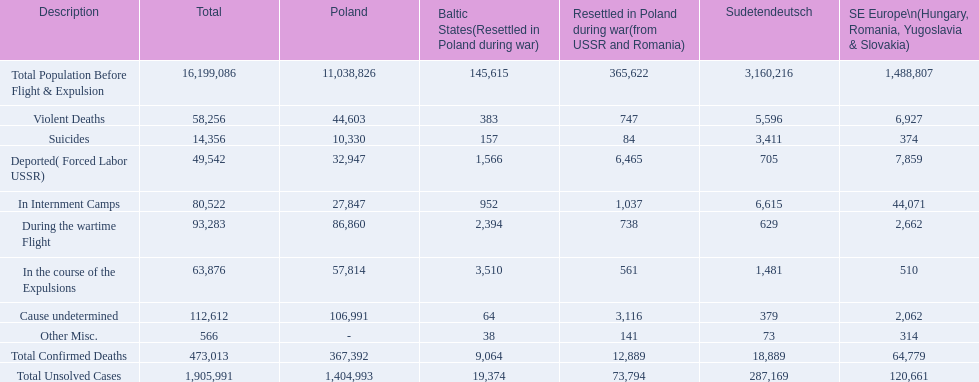What are the different descriptions? Total Population Before Flight & Expulsion, Violent Deaths, Suicides, Deported( Forced Labor USSR), In Internment Camps, During the wartime Flight, In the course of the Expulsions, Cause undetermined, Other Misc., Total Confirmed Deaths, Total Unsolved Cases. What is the total death count? 16,199,086, 58,256, 14,356, 49,542, 80,522, 93,283, 63,876, 112,612, 566, 473,013, 1,905,991. What is the count of only violent deaths? 58,256. 